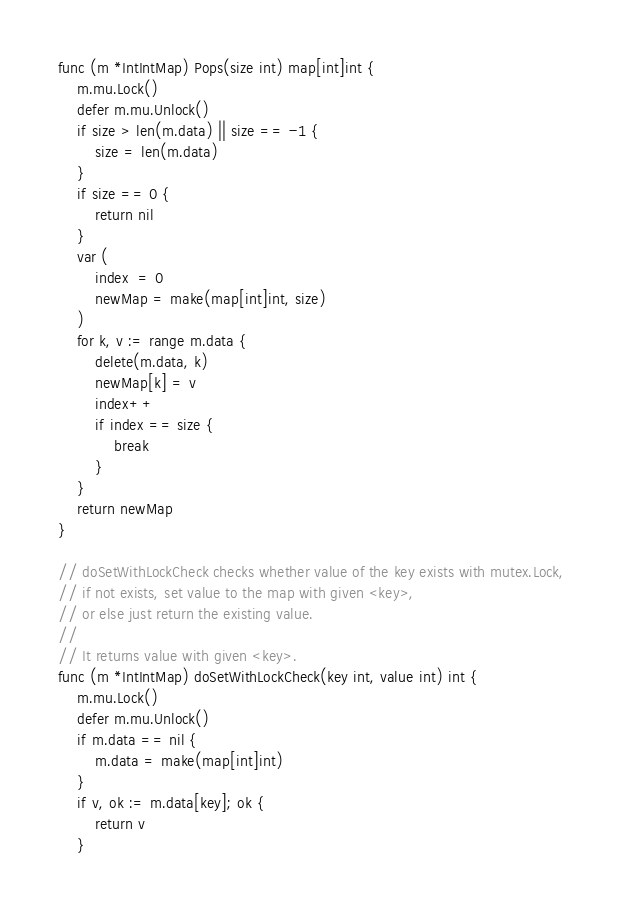Convert code to text. <code><loc_0><loc_0><loc_500><loc_500><_Go_>func (m *IntIntMap) Pops(size int) map[int]int {
	m.mu.Lock()
	defer m.mu.Unlock()
	if size > len(m.data) || size == -1 {
		size = len(m.data)
	}
	if size == 0 {
		return nil
	}
	var (
		index  = 0
		newMap = make(map[int]int, size)
	)
	for k, v := range m.data {
		delete(m.data, k)
		newMap[k] = v
		index++
		if index == size {
			break
		}
	}
	return newMap
}

// doSetWithLockCheck checks whether value of the key exists with mutex.Lock,
// if not exists, set value to the map with given <key>,
// or else just return the existing value.
//
// It returns value with given <key>.
func (m *IntIntMap) doSetWithLockCheck(key int, value int) int {
	m.mu.Lock()
	defer m.mu.Unlock()
	if m.data == nil {
		m.data = make(map[int]int)
	}
	if v, ok := m.data[key]; ok {
		return v
	}</code> 